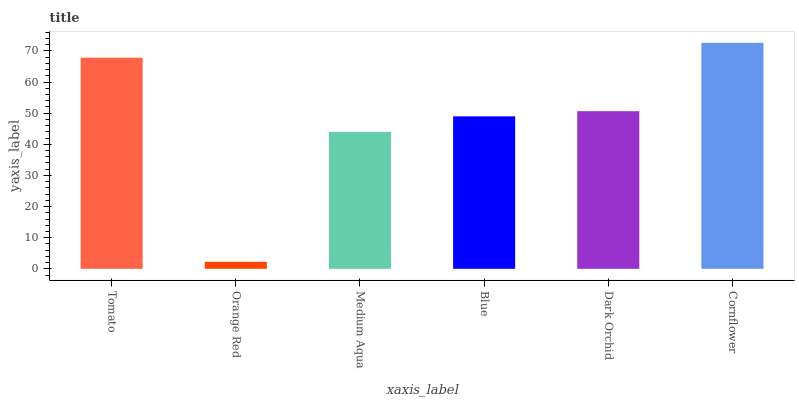Is Orange Red the minimum?
Answer yes or no. Yes. Is Cornflower the maximum?
Answer yes or no. Yes. Is Medium Aqua the minimum?
Answer yes or no. No. Is Medium Aqua the maximum?
Answer yes or no. No. Is Medium Aqua greater than Orange Red?
Answer yes or no. Yes. Is Orange Red less than Medium Aqua?
Answer yes or no. Yes. Is Orange Red greater than Medium Aqua?
Answer yes or no. No. Is Medium Aqua less than Orange Red?
Answer yes or no. No. Is Dark Orchid the high median?
Answer yes or no. Yes. Is Blue the low median?
Answer yes or no. Yes. Is Orange Red the high median?
Answer yes or no. No. Is Medium Aqua the low median?
Answer yes or no. No. 